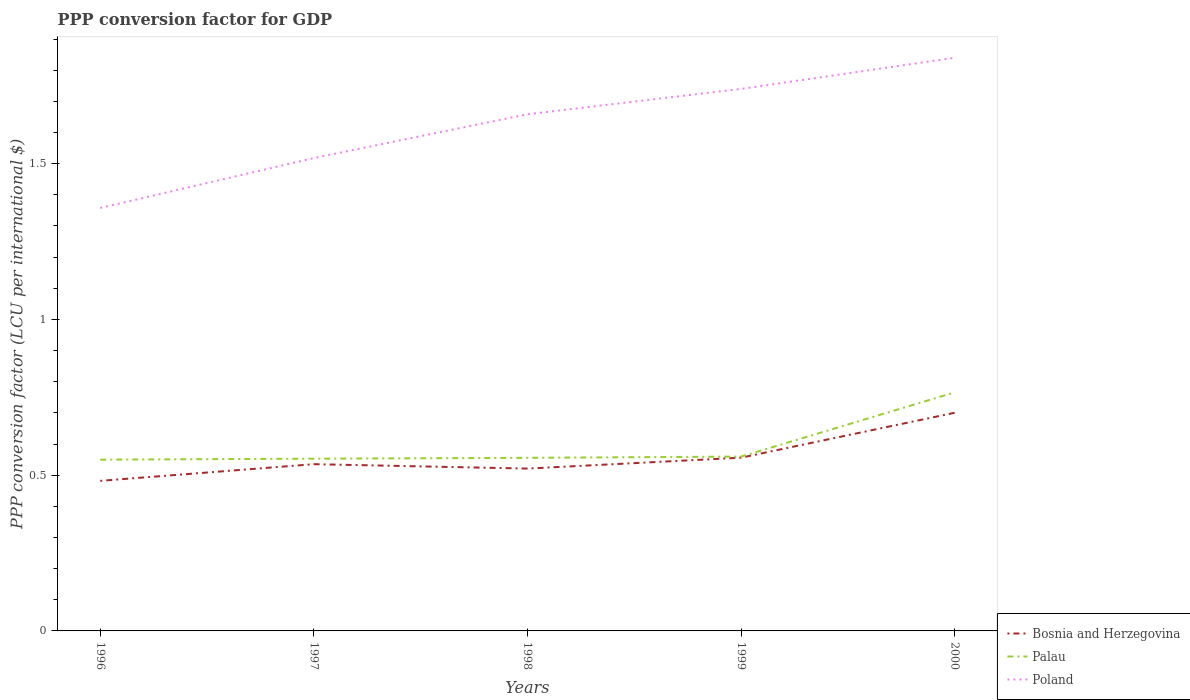Is the number of lines equal to the number of legend labels?
Provide a short and direct response. Yes. Across all years, what is the maximum PPP conversion factor for GDP in Bosnia and Herzegovina?
Give a very brief answer. 0.48. In which year was the PPP conversion factor for GDP in Bosnia and Herzegovina maximum?
Keep it short and to the point. 1996. What is the total PPP conversion factor for GDP in Poland in the graph?
Keep it short and to the point. -0.22. What is the difference between the highest and the second highest PPP conversion factor for GDP in Bosnia and Herzegovina?
Offer a very short reply. 0.22. What is the difference between the highest and the lowest PPP conversion factor for GDP in Poland?
Ensure brevity in your answer.  3. How many lines are there?
Provide a succinct answer. 3. What is the difference between two consecutive major ticks on the Y-axis?
Offer a terse response. 0.5. What is the title of the graph?
Your response must be concise. PPP conversion factor for GDP. Does "World" appear as one of the legend labels in the graph?
Your response must be concise. No. What is the label or title of the Y-axis?
Your response must be concise. PPP conversion factor (LCU per international $). What is the PPP conversion factor (LCU per international $) in Bosnia and Herzegovina in 1996?
Your answer should be very brief. 0.48. What is the PPP conversion factor (LCU per international $) of Palau in 1996?
Offer a terse response. 0.55. What is the PPP conversion factor (LCU per international $) of Poland in 1996?
Keep it short and to the point. 1.36. What is the PPP conversion factor (LCU per international $) in Bosnia and Herzegovina in 1997?
Your answer should be very brief. 0.54. What is the PPP conversion factor (LCU per international $) in Palau in 1997?
Your answer should be very brief. 0.55. What is the PPP conversion factor (LCU per international $) of Poland in 1997?
Offer a terse response. 1.52. What is the PPP conversion factor (LCU per international $) of Bosnia and Herzegovina in 1998?
Offer a very short reply. 0.52. What is the PPP conversion factor (LCU per international $) of Palau in 1998?
Offer a terse response. 0.56. What is the PPP conversion factor (LCU per international $) in Poland in 1998?
Ensure brevity in your answer.  1.66. What is the PPP conversion factor (LCU per international $) of Bosnia and Herzegovina in 1999?
Provide a succinct answer. 0.56. What is the PPP conversion factor (LCU per international $) in Palau in 1999?
Your response must be concise. 0.56. What is the PPP conversion factor (LCU per international $) of Poland in 1999?
Give a very brief answer. 1.74. What is the PPP conversion factor (LCU per international $) of Bosnia and Herzegovina in 2000?
Your answer should be very brief. 0.7. What is the PPP conversion factor (LCU per international $) of Palau in 2000?
Make the answer very short. 0.77. What is the PPP conversion factor (LCU per international $) of Poland in 2000?
Provide a succinct answer. 1.84. Across all years, what is the maximum PPP conversion factor (LCU per international $) of Bosnia and Herzegovina?
Make the answer very short. 0.7. Across all years, what is the maximum PPP conversion factor (LCU per international $) in Palau?
Your response must be concise. 0.77. Across all years, what is the maximum PPP conversion factor (LCU per international $) of Poland?
Give a very brief answer. 1.84. Across all years, what is the minimum PPP conversion factor (LCU per international $) of Bosnia and Herzegovina?
Ensure brevity in your answer.  0.48. Across all years, what is the minimum PPP conversion factor (LCU per international $) in Palau?
Your answer should be very brief. 0.55. Across all years, what is the minimum PPP conversion factor (LCU per international $) of Poland?
Your response must be concise. 1.36. What is the total PPP conversion factor (LCU per international $) of Bosnia and Herzegovina in the graph?
Provide a succinct answer. 2.79. What is the total PPP conversion factor (LCU per international $) in Palau in the graph?
Keep it short and to the point. 2.98. What is the total PPP conversion factor (LCU per international $) of Poland in the graph?
Provide a succinct answer. 8.12. What is the difference between the PPP conversion factor (LCU per international $) of Bosnia and Herzegovina in 1996 and that in 1997?
Provide a short and direct response. -0.05. What is the difference between the PPP conversion factor (LCU per international $) of Palau in 1996 and that in 1997?
Offer a very short reply. -0. What is the difference between the PPP conversion factor (LCU per international $) of Poland in 1996 and that in 1997?
Ensure brevity in your answer.  -0.16. What is the difference between the PPP conversion factor (LCU per international $) of Bosnia and Herzegovina in 1996 and that in 1998?
Offer a terse response. -0.04. What is the difference between the PPP conversion factor (LCU per international $) of Palau in 1996 and that in 1998?
Keep it short and to the point. -0.01. What is the difference between the PPP conversion factor (LCU per international $) of Poland in 1996 and that in 1998?
Keep it short and to the point. -0.3. What is the difference between the PPP conversion factor (LCU per international $) in Bosnia and Herzegovina in 1996 and that in 1999?
Make the answer very short. -0.07. What is the difference between the PPP conversion factor (LCU per international $) in Palau in 1996 and that in 1999?
Ensure brevity in your answer.  -0.01. What is the difference between the PPP conversion factor (LCU per international $) of Poland in 1996 and that in 1999?
Ensure brevity in your answer.  -0.38. What is the difference between the PPP conversion factor (LCU per international $) of Bosnia and Herzegovina in 1996 and that in 2000?
Your response must be concise. -0.22. What is the difference between the PPP conversion factor (LCU per international $) in Palau in 1996 and that in 2000?
Give a very brief answer. -0.22. What is the difference between the PPP conversion factor (LCU per international $) in Poland in 1996 and that in 2000?
Your response must be concise. -0.48. What is the difference between the PPP conversion factor (LCU per international $) of Bosnia and Herzegovina in 1997 and that in 1998?
Keep it short and to the point. 0.01. What is the difference between the PPP conversion factor (LCU per international $) in Palau in 1997 and that in 1998?
Your answer should be very brief. -0. What is the difference between the PPP conversion factor (LCU per international $) in Poland in 1997 and that in 1998?
Offer a terse response. -0.14. What is the difference between the PPP conversion factor (LCU per international $) in Bosnia and Herzegovina in 1997 and that in 1999?
Provide a succinct answer. -0.02. What is the difference between the PPP conversion factor (LCU per international $) in Palau in 1997 and that in 1999?
Give a very brief answer. -0.01. What is the difference between the PPP conversion factor (LCU per international $) of Poland in 1997 and that in 1999?
Your answer should be very brief. -0.22. What is the difference between the PPP conversion factor (LCU per international $) of Bosnia and Herzegovina in 1997 and that in 2000?
Your response must be concise. -0.17. What is the difference between the PPP conversion factor (LCU per international $) of Palau in 1997 and that in 2000?
Give a very brief answer. -0.21. What is the difference between the PPP conversion factor (LCU per international $) of Poland in 1997 and that in 2000?
Offer a terse response. -0.32. What is the difference between the PPP conversion factor (LCU per international $) in Bosnia and Herzegovina in 1998 and that in 1999?
Make the answer very short. -0.04. What is the difference between the PPP conversion factor (LCU per international $) in Palau in 1998 and that in 1999?
Your answer should be compact. -0. What is the difference between the PPP conversion factor (LCU per international $) of Poland in 1998 and that in 1999?
Your response must be concise. -0.08. What is the difference between the PPP conversion factor (LCU per international $) in Bosnia and Herzegovina in 1998 and that in 2000?
Your answer should be compact. -0.18. What is the difference between the PPP conversion factor (LCU per international $) of Palau in 1998 and that in 2000?
Your answer should be compact. -0.21. What is the difference between the PPP conversion factor (LCU per international $) in Poland in 1998 and that in 2000?
Your response must be concise. -0.18. What is the difference between the PPP conversion factor (LCU per international $) in Bosnia and Herzegovina in 1999 and that in 2000?
Your answer should be very brief. -0.14. What is the difference between the PPP conversion factor (LCU per international $) in Palau in 1999 and that in 2000?
Offer a terse response. -0.21. What is the difference between the PPP conversion factor (LCU per international $) of Poland in 1999 and that in 2000?
Provide a succinct answer. -0.1. What is the difference between the PPP conversion factor (LCU per international $) of Bosnia and Herzegovina in 1996 and the PPP conversion factor (LCU per international $) of Palau in 1997?
Give a very brief answer. -0.07. What is the difference between the PPP conversion factor (LCU per international $) of Bosnia and Herzegovina in 1996 and the PPP conversion factor (LCU per international $) of Poland in 1997?
Offer a very short reply. -1.04. What is the difference between the PPP conversion factor (LCU per international $) in Palau in 1996 and the PPP conversion factor (LCU per international $) in Poland in 1997?
Provide a short and direct response. -0.97. What is the difference between the PPP conversion factor (LCU per international $) in Bosnia and Herzegovina in 1996 and the PPP conversion factor (LCU per international $) in Palau in 1998?
Your response must be concise. -0.07. What is the difference between the PPP conversion factor (LCU per international $) in Bosnia and Herzegovina in 1996 and the PPP conversion factor (LCU per international $) in Poland in 1998?
Make the answer very short. -1.18. What is the difference between the PPP conversion factor (LCU per international $) in Palau in 1996 and the PPP conversion factor (LCU per international $) in Poland in 1998?
Make the answer very short. -1.11. What is the difference between the PPP conversion factor (LCU per international $) in Bosnia and Herzegovina in 1996 and the PPP conversion factor (LCU per international $) in Palau in 1999?
Your response must be concise. -0.08. What is the difference between the PPP conversion factor (LCU per international $) of Bosnia and Herzegovina in 1996 and the PPP conversion factor (LCU per international $) of Poland in 1999?
Your response must be concise. -1.26. What is the difference between the PPP conversion factor (LCU per international $) of Palau in 1996 and the PPP conversion factor (LCU per international $) of Poland in 1999?
Your answer should be very brief. -1.19. What is the difference between the PPP conversion factor (LCU per international $) of Bosnia and Herzegovina in 1996 and the PPP conversion factor (LCU per international $) of Palau in 2000?
Provide a succinct answer. -0.28. What is the difference between the PPP conversion factor (LCU per international $) of Bosnia and Herzegovina in 1996 and the PPP conversion factor (LCU per international $) of Poland in 2000?
Keep it short and to the point. -1.36. What is the difference between the PPP conversion factor (LCU per international $) of Palau in 1996 and the PPP conversion factor (LCU per international $) of Poland in 2000?
Your answer should be compact. -1.29. What is the difference between the PPP conversion factor (LCU per international $) of Bosnia and Herzegovina in 1997 and the PPP conversion factor (LCU per international $) of Palau in 1998?
Keep it short and to the point. -0.02. What is the difference between the PPP conversion factor (LCU per international $) of Bosnia and Herzegovina in 1997 and the PPP conversion factor (LCU per international $) of Poland in 1998?
Give a very brief answer. -1.12. What is the difference between the PPP conversion factor (LCU per international $) of Palau in 1997 and the PPP conversion factor (LCU per international $) of Poland in 1998?
Give a very brief answer. -1.11. What is the difference between the PPP conversion factor (LCU per international $) of Bosnia and Herzegovina in 1997 and the PPP conversion factor (LCU per international $) of Palau in 1999?
Provide a short and direct response. -0.02. What is the difference between the PPP conversion factor (LCU per international $) of Bosnia and Herzegovina in 1997 and the PPP conversion factor (LCU per international $) of Poland in 1999?
Offer a very short reply. -1.2. What is the difference between the PPP conversion factor (LCU per international $) in Palau in 1997 and the PPP conversion factor (LCU per international $) in Poland in 1999?
Keep it short and to the point. -1.19. What is the difference between the PPP conversion factor (LCU per international $) in Bosnia and Herzegovina in 1997 and the PPP conversion factor (LCU per international $) in Palau in 2000?
Offer a terse response. -0.23. What is the difference between the PPP conversion factor (LCU per international $) in Bosnia and Herzegovina in 1997 and the PPP conversion factor (LCU per international $) in Poland in 2000?
Provide a succinct answer. -1.3. What is the difference between the PPP conversion factor (LCU per international $) in Palau in 1997 and the PPP conversion factor (LCU per international $) in Poland in 2000?
Your answer should be very brief. -1.29. What is the difference between the PPP conversion factor (LCU per international $) of Bosnia and Herzegovina in 1998 and the PPP conversion factor (LCU per international $) of Palau in 1999?
Make the answer very short. -0.04. What is the difference between the PPP conversion factor (LCU per international $) of Bosnia and Herzegovina in 1998 and the PPP conversion factor (LCU per international $) of Poland in 1999?
Your response must be concise. -1.22. What is the difference between the PPP conversion factor (LCU per international $) in Palau in 1998 and the PPP conversion factor (LCU per international $) in Poland in 1999?
Your answer should be very brief. -1.18. What is the difference between the PPP conversion factor (LCU per international $) of Bosnia and Herzegovina in 1998 and the PPP conversion factor (LCU per international $) of Palau in 2000?
Provide a short and direct response. -0.24. What is the difference between the PPP conversion factor (LCU per international $) of Bosnia and Herzegovina in 1998 and the PPP conversion factor (LCU per international $) of Poland in 2000?
Give a very brief answer. -1.32. What is the difference between the PPP conversion factor (LCU per international $) of Palau in 1998 and the PPP conversion factor (LCU per international $) of Poland in 2000?
Provide a short and direct response. -1.28. What is the difference between the PPP conversion factor (LCU per international $) of Bosnia and Herzegovina in 1999 and the PPP conversion factor (LCU per international $) of Palau in 2000?
Keep it short and to the point. -0.21. What is the difference between the PPP conversion factor (LCU per international $) of Bosnia and Herzegovina in 1999 and the PPP conversion factor (LCU per international $) of Poland in 2000?
Your answer should be compact. -1.28. What is the difference between the PPP conversion factor (LCU per international $) in Palau in 1999 and the PPP conversion factor (LCU per international $) in Poland in 2000?
Your response must be concise. -1.28. What is the average PPP conversion factor (LCU per international $) in Bosnia and Herzegovina per year?
Your answer should be very brief. 0.56. What is the average PPP conversion factor (LCU per international $) in Palau per year?
Ensure brevity in your answer.  0.6. What is the average PPP conversion factor (LCU per international $) in Poland per year?
Offer a terse response. 1.62. In the year 1996, what is the difference between the PPP conversion factor (LCU per international $) in Bosnia and Herzegovina and PPP conversion factor (LCU per international $) in Palau?
Your answer should be compact. -0.07. In the year 1996, what is the difference between the PPP conversion factor (LCU per international $) in Bosnia and Herzegovina and PPP conversion factor (LCU per international $) in Poland?
Keep it short and to the point. -0.88. In the year 1996, what is the difference between the PPP conversion factor (LCU per international $) of Palau and PPP conversion factor (LCU per international $) of Poland?
Make the answer very short. -0.81. In the year 1997, what is the difference between the PPP conversion factor (LCU per international $) of Bosnia and Herzegovina and PPP conversion factor (LCU per international $) of Palau?
Keep it short and to the point. -0.02. In the year 1997, what is the difference between the PPP conversion factor (LCU per international $) in Bosnia and Herzegovina and PPP conversion factor (LCU per international $) in Poland?
Keep it short and to the point. -0.98. In the year 1997, what is the difference between the PPP conversion factor (LCU per international $) in Palau and PPP conversion factor (LCU per international $) in Poland?
Offer a very short reply. -0.97. In the year 1998, what is the difference between the PPP conversion factor (LCU per international $) in Bosnia and Herzegovina and PPP conversion factor (LCU per international $) in Palau?
Provide a short and direct response. -0.03. In the year 1998, what is the difference between the PPP conversion factor (LCU per international $) in Bosnia and Herzegovina and PPP conversion factor (LCU per international $) in Poland?
Ensure brevity in your answer.  -1.14. In the year 1998, what is the difference between the PPP conversion factor (LCU per international $) in Palau and PPP conversion factor (LCU per international $) in Poland?
Make the answer very short. -1.1. In the year 1999, what is the difference between the PPP conversion factor (LCU per international $) of Bosnia and Herzegovina and PPP conversion factor (LCU per international $) of Palau?
Provide a short and direct response. -0. In the year 1999, what is the difference between the PPP conversion factor (LCU per international $) in Bosnia and Herzegovina and PPP conversion factor (LCU per international $) in Poland?
Provide a succinct answer. -1.18. In the year 1999, what is the difference between the PPP conversion factor (LCU per international $) in Palau and PPP conversion factor (LCU per international $) in Poland?
Ensure brevity in your answer.  -1.18. In the year 2000, what is the difference between the PPP conversion factor (LCU per international $) of Bosnia and Herzegovina and PPP conversion factor (LCU per international $) of Palau?
Keep it short and to the point. -0.07. In the year 2000, what is the difference between the PPP conversion factor (LCU per international $) of Bosnia and Herzegovina and PPP conversion factor (LCU per international $) of Poland?
Offer a very short reply. -1.14. In the year 2000, what is the difference between the PPP conversion factor (LCU per international $) of Palau and PPP conversion factor (LCU per international $) of Poland?
Your answer should be very brief. -1.07. What is the ratio of the PPP conversion factor (LCU per international $) in Bosnia and Herzegovina in 1996 to that in 1997?
Offer a very short reply. 0.9. What is the ratio of the PPP conversion factor (LCU per international $) in Poland in 1996 to that in 1997?
Provide a succinct answer. 0.89. What is the ratio of the PPP conversion factor (LCU per international $) of Bosnia and Herzegovina in 1996 to that in 1998?
Your answer should be very brief. 0.92. What is the ratio of the PPP conversion factor (LCU per international $) of Palau in 1996 to that in 1998?
Make the answer very short. 0.99. What is the ratio of the PPP conversion factor (LCU per international $) of Poland in 1996 to that in 1998?
Offer a very short reply. 0.82. What is the ratio of the PPP conversion factor (LCU per international $) of Bosnia and Herzegovina in 1996 to that in 1999?
Ensure brevity in your answer.  0.87. What is the ratio of the PPP conversion factor (LCU per international $) of Palau in 1996 to that in 1999?
Provide a succinct answer. 0.98. What is the ratio of the PPP conversion factor (LCU per international $) of Poland in 1996 to that in 1999?
Give a very brief answer. 0.78. What is the ratio of the PPP conversion factor (LCU per international $) of Bosnia and Herzegovina in 1996 to that in 2000?
Your answer should be very brief. 0.69. What is the ratio of the PPP conversion factor (LCU per international $) of Palau in 1996 to that in 2000?
Provide a short and direct response. 0.72. What is the ratio of the PPP conversion factor (LCU per international $) in Poland in 1996 to that in 2000?
Provide a succinct answer. 0.74. What is the ratio of the PPP conversion factor (LCU per international $) of Bosnia and Herzegovina in 1997 to that in 1998?
Offer a terse response. 1.03. What is the ratio of the PPP conversion factor (LCU per international $) of Poland in 1997 to that in 1998?
Keep it short and to the point. 0.92. What is the ratio of the PPP conversion factor (LCU per international $) of Bosnia and Herzegovina in 1997 to that in 1999?
Give a very brief answer. 0.96. What is the ratio of the PPP conversion factor (LCU per international $) of Palau in 1997 to that in 1999?
Your response must be concise. 0.99. What is the ratio of the PPP conversion factor (LCU per international $) of Poland in 1997 to that in 1999?
Your answer should be compact. 0.87. What is the ratio of the PPP conversion factor (LCU per international $) of Bosnia and Herzegovina in 1997 to that in 2000?
Ensure brevity in your answer.  0.76. What is the ratio of the PPP conversion factor (LCU per international $) in Palau in 1997 to that in 2000?
Offer a terse response. 0.72. What is the ratio of the PPP conversion factor (LCU per international $) of Poland in 1997 to that in 2000?
Make the answer very short. 0.82. What is the ratio of the PPP conversion factor (LCU per international $) in Bosnia and Herzegovina in 1998 to that in 1999?
Offer a very short reply. 0.94. What is the ratio of the PPP conversion factor (LCU per international $) of Palau in 1998 to that in 1999?
Make the answer very short. 0.99. What is the ratio of the PPP conversion factor (LCU per international $) in Poland in 1998 to that in 1999?
Make the answer very short. 0.95. What is the ratio of the PPP conversion factor (LCU per international $) of Bosnia and Herzegovina in 1998 to that in 2000?
Ensure brevity in your answer.  0.74. What is the ratio of the PPP conversion factor (LCU per international $) in Palau in 1998 to that in 2000?
Your response must be concise. 0.73. What is the ratio of the PPP conversion factor (LCU per international $) in Poland in 1998 to that in 2000?
Your response must be concise. 0.9. What is the ratio of the PPP conversion factor (LCU per international $) in Bosnia and Herzegovina in 1999 to that in 2000?
Offer a terse response. 0.79. What is the ratio of the PPP conversion factor (LCU per international $) of Palau in 1999 to that in 2000?
Your answer should be compact. 0.73. What is the ratio of the PPP conversion factor (LCU per international $) of Poland in 1999 to that in 2000?
Make the answer very short. 0.95. What is the difference between the highest and the second highest PPP conversion factor (LCU per international $) of Bosnia and Herzegovina?
Your answer should be very brief. 0.14. What is the difference between the highest and the second highest PPP conversion factor (LCU per international $) in Palau?
Your answer should be compact. 0.21. What is the difference between the highest and the second highest PPP conversion factor (LCU per international $) of Poland?
Ensure brevity in your answer.  0.1. What is the difference between the highest and the lowest PPP conversion factor (LCU per international $) in Bosnia and Herzegovina?
Provide a short and direct response. 0.22. What is the difference between the highest and the lowest PPP conversion factor (LCU per international $) in Palau?
Your answer should be very brief. 0.22. What is the difference between the highest and the lowest PPP conversion factor (LCU per international $) of Poland?
Keep it short and to the point. 0.48. 